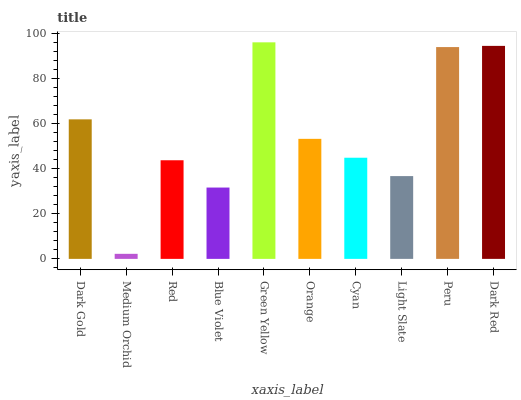Is Medium Orchid the minimum?
Answer yes or no. Yes. Is Green Yellow the maximum?
Answer yes or no. Yes. Is Red the minimum?
Answer yes or no. No. Is Red the maximum?
Answer yes or no. No. Is Red greater than Medium Orchid?
Answer yes or no. Yes. Is Medium Orchid less than Red?
Answer yes or no. Yes. Is Medium Orchid greater than Red?
Answer yes or no. No. Is Red less than Medium Orchid?
Answer yes or no. No. Is Orange the high median?
Answer yes or no. Yes. Is Cyan the low median?
Answer yes or no. Yes. Is Dark Red the high median?
Answer yes or no. No. Is Light Slate the low median?
Answer yes or no. No. 